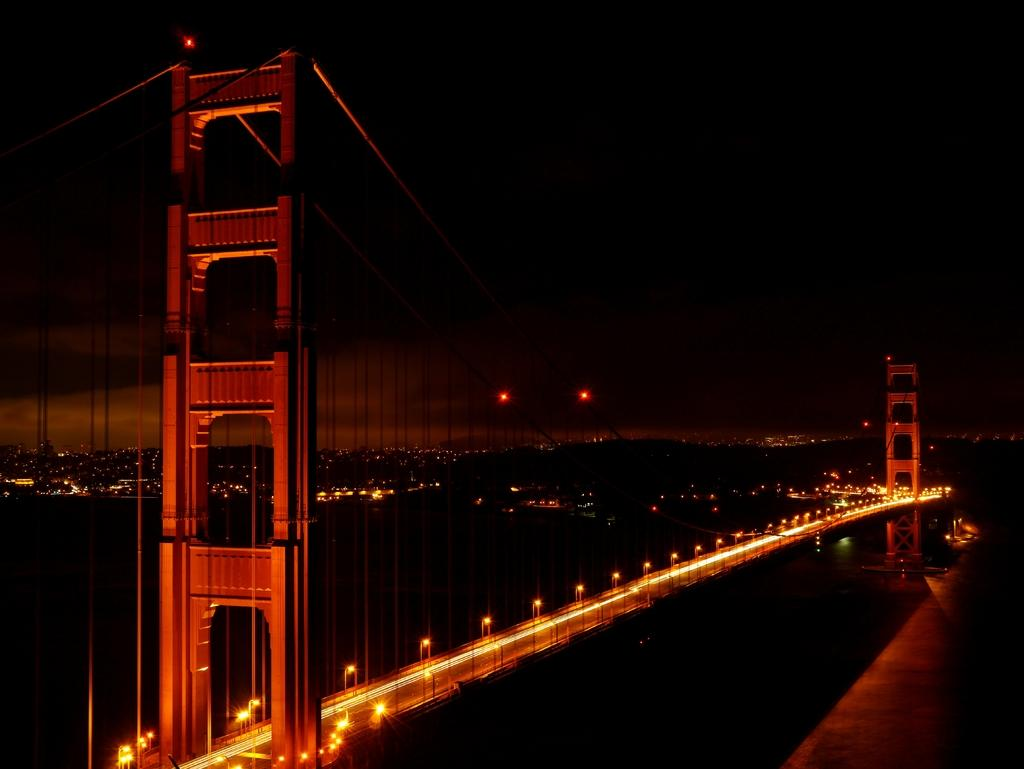What is the lighting condition in the image? The image was taken in the dark. What structure can be seen in the image? There is a bridge in the image. How many towers are visible in the image? There are two towers in the image. What can be seen in the background of the image? There are many lights visible in the background of the image. How many men are visible in the image? There is no mention of men in the provided facts, so we cannot determine the number of men present in the image. 